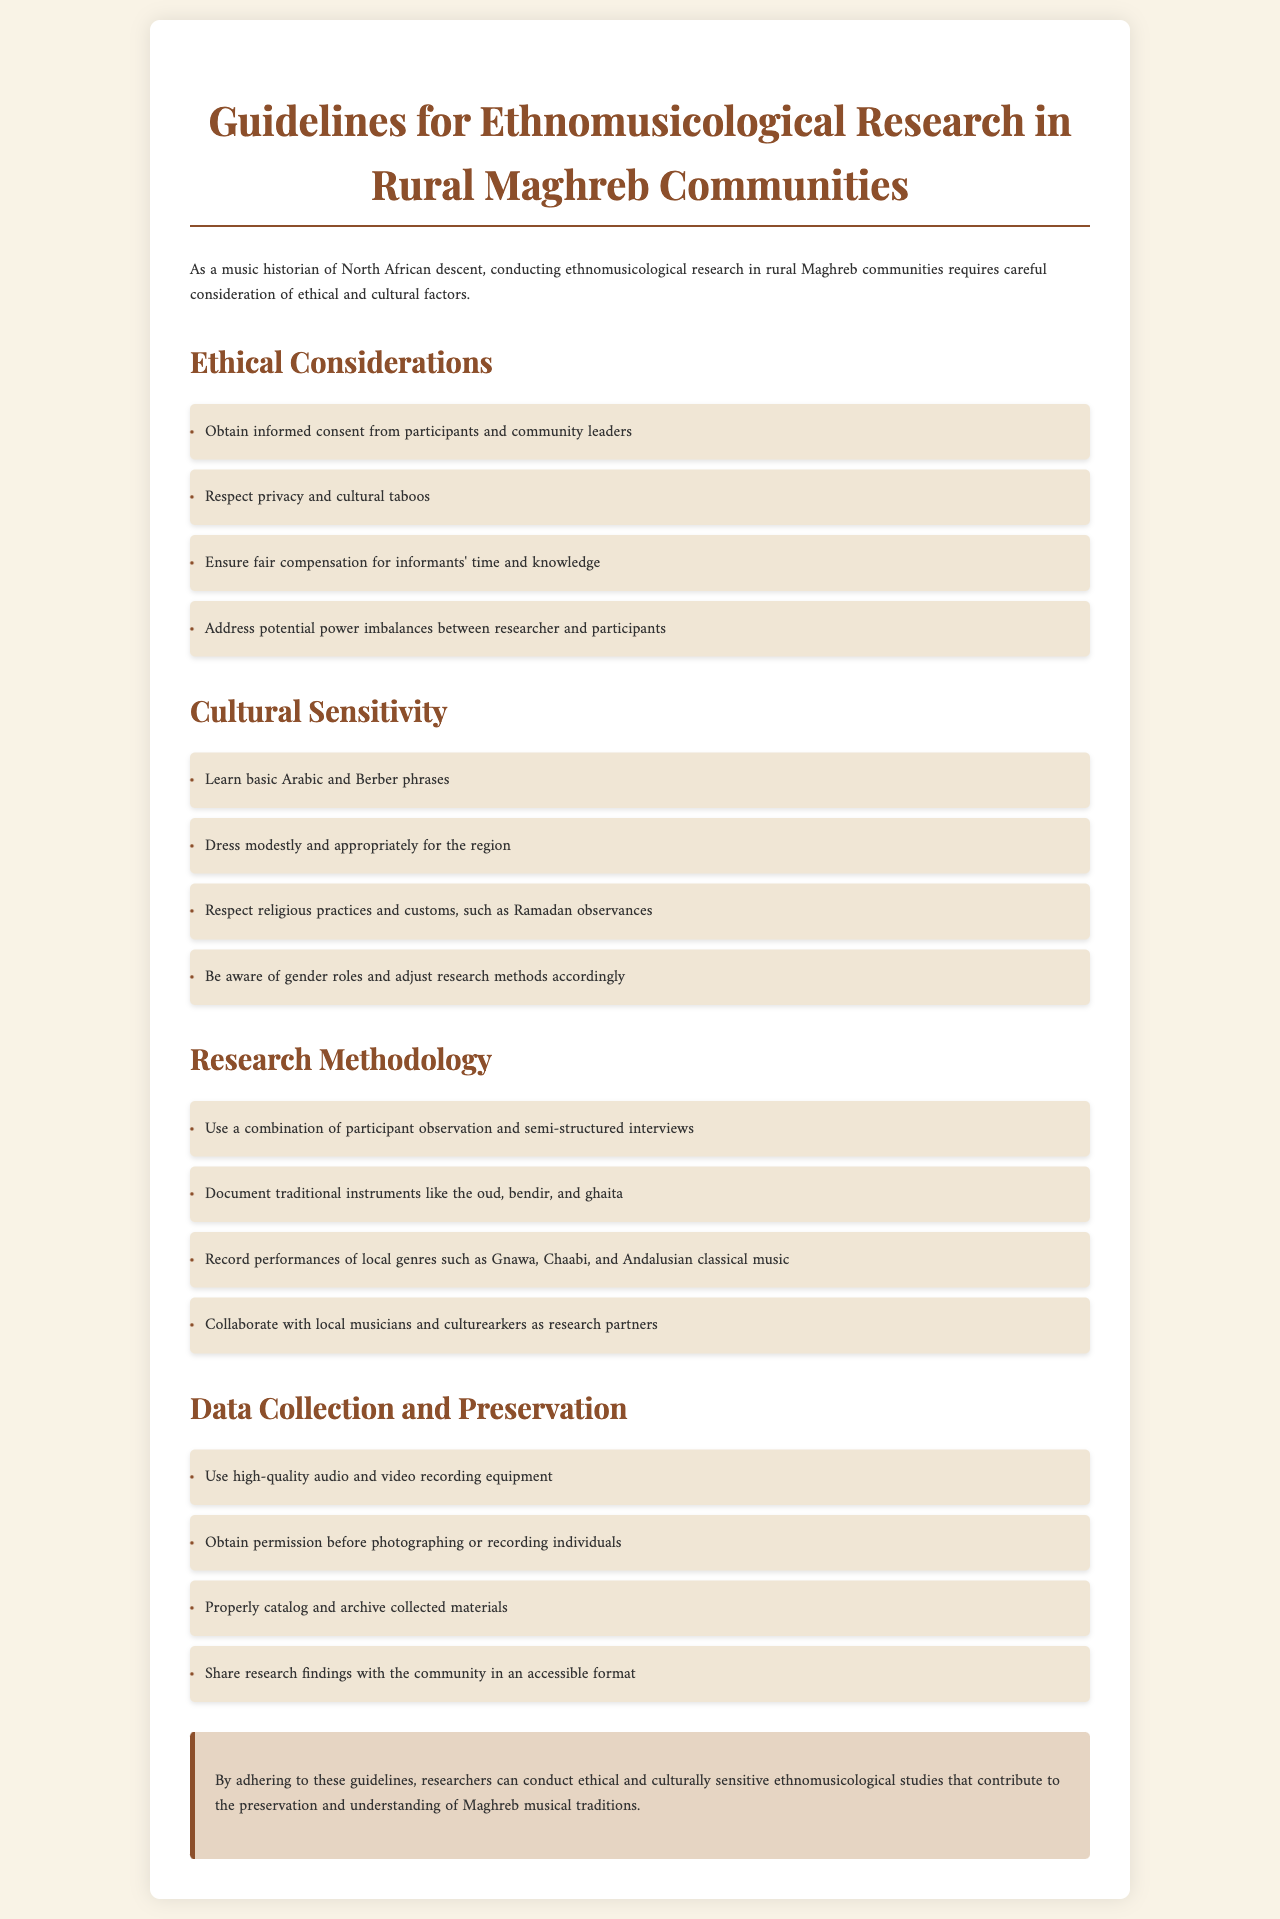what is the title of the document? The title of the document is stated at the beginning, providing a clear indication of its content.
Answer: Guidelines for Ethnomusicological Research in Rural Maghreb Communities what should researchers obtain from participants? The document specifies a requirement for ethical consideration regarding participant involvement in research.
Answer: Informed consent which traditional instrument is mentioned first? The document lists various traditional instruments, and the order reflects their importance in the study.
Answer: Oud what is a recommended practice during Ramadan? The document highlights the necessity of respecting local customs, particularly during specific religious observances.
Answer: Respect religious practices how many main sections are in the document? The document's layout includes distinct sections that organize the information effectively.
Answer: Four what type of interviews does the document suggest? The methodology section indicates a specific type of interaction with participants to gather data.
Answer: Semi-structured interviews what is the purpose of sharing research findings? The conclusion emphasizes the importance of making research accessible to the community.
Answer: Preservation and understanding of Maghreb musical traditions what should researchers ensure for informants? The ethical considerations include fair treatment for individuals providing information and insight.
Answer: Fair compensation 